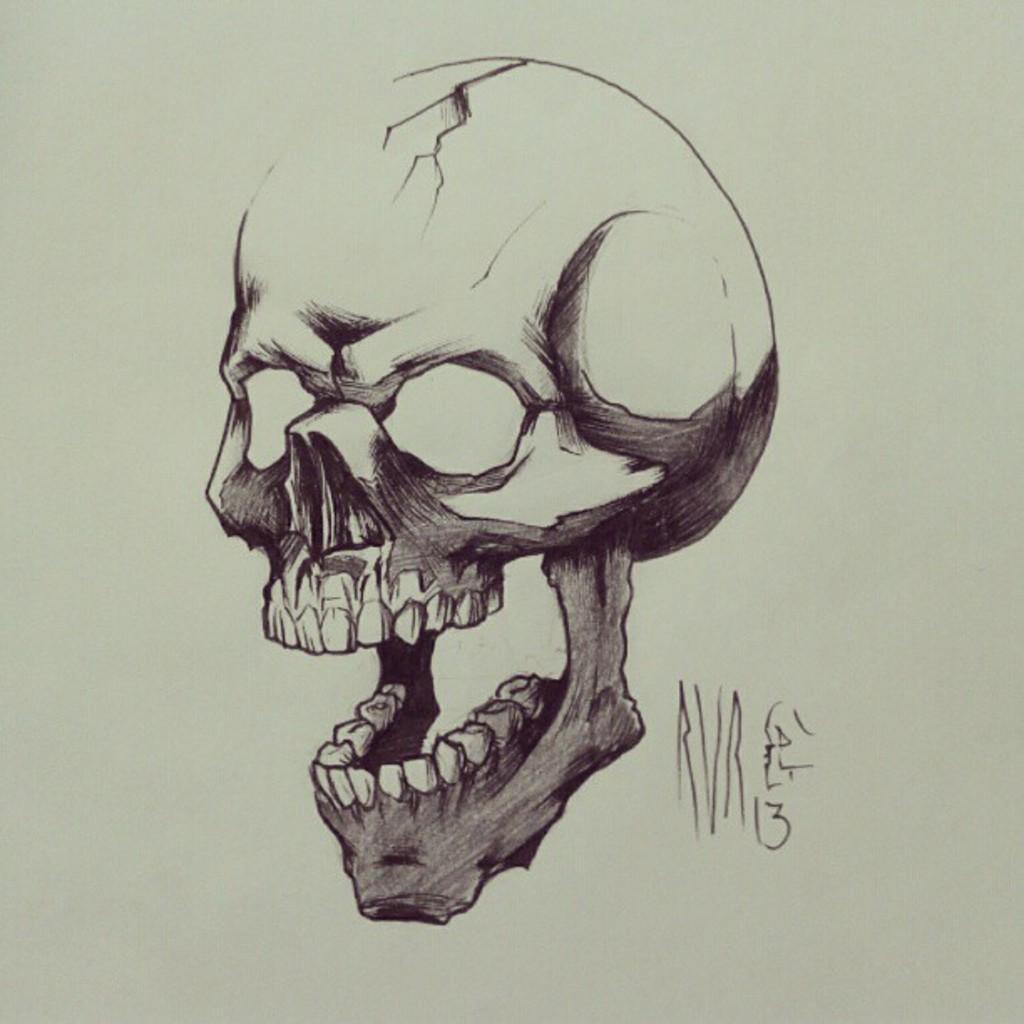In one or two sentences, can you explain what this image depicts? In this image we can see a drawing of a skull with group of teeth attached to it. 